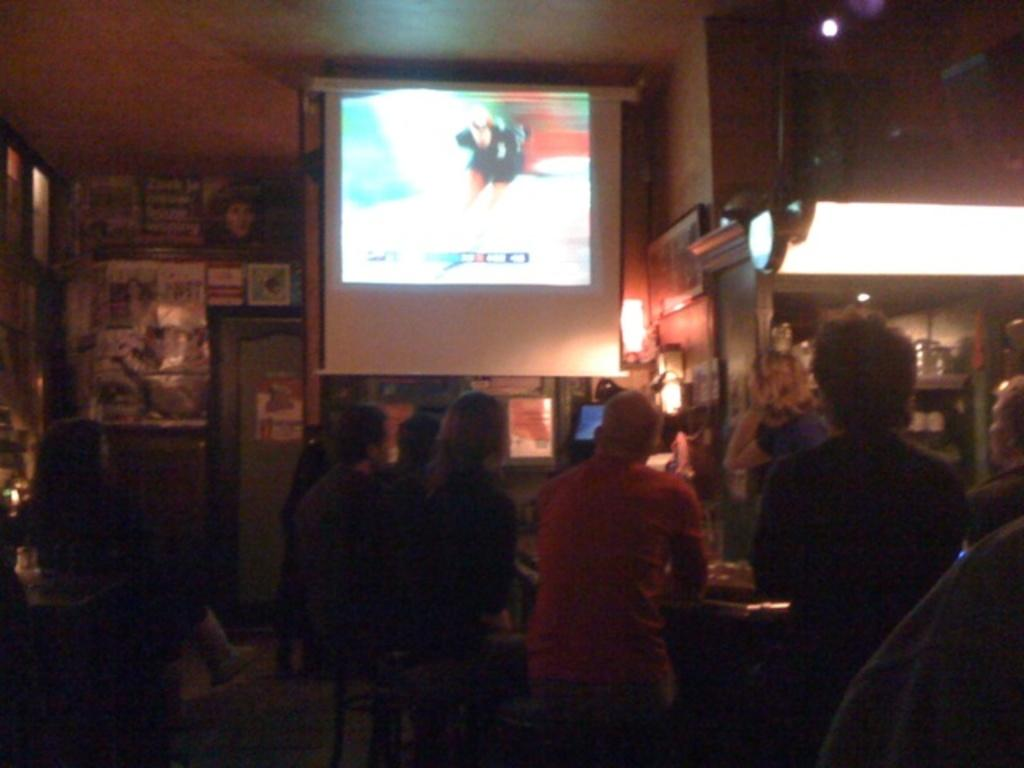What are the people in the image doing? People are sitting on tables in the image. What can be seen on the wall in the image? There are posters and a board on the wall in the image. What is the purpose of the screen in the image? The screen's purpose is not specified, but it is visible in the image. Can you describe the lighting in the image? Light is visible in the image, but the source or intensity is not specified. What is the nature of the objects in the race? The nature of the objects in the race is not specified, but there are objects in the race. Can you tell me how many farmers are using the vessels in the image? There are no farmers or vessels present in the image. What type of house is depicted on the board in the image? There is no house depicted on the board in the image; it only mentions objects in the race. 